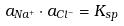Convert formula to latex. <formula><loc_0><loc_0><loc_500><loc_500>a _ { N a ^ { + } } \cdot a _ { C l ^ { - } } = K _ { s p }</formula> 